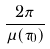Convert formula to latex. <formula><loc_0><loc_0><loc_500><loc_500>\frac { 2 \pi } { \mu ( \tau _ { 0 } ) }</formula> 